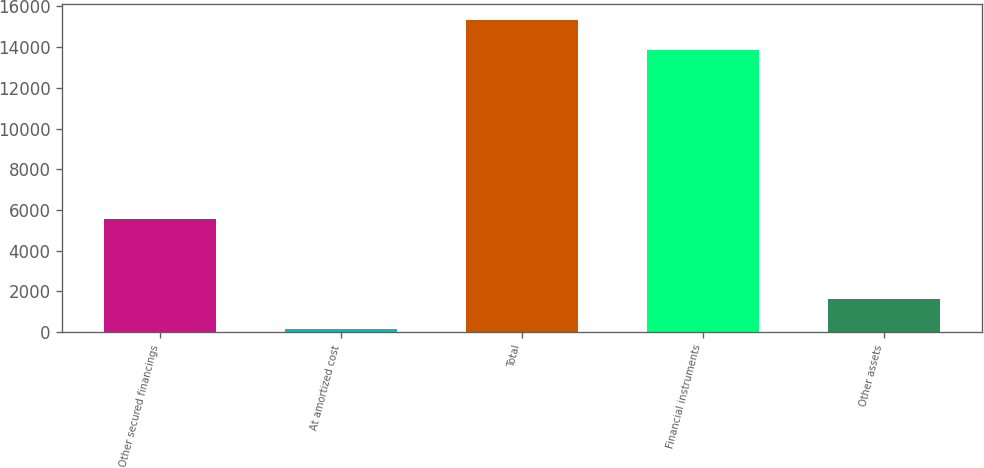Convert chart to OTSL. <chart><loc_0><loc_0><loc_500><loc_500><bar_chart><fcel>Other secured financings<fcel>At amortized cost<fcel>Total<fcel>Financial instruments<fcel>Other assets<nl><fcel>5562<fcel>145<fcel>15352.2<fcel>13858<fcel>1639.2<nl></chart> 